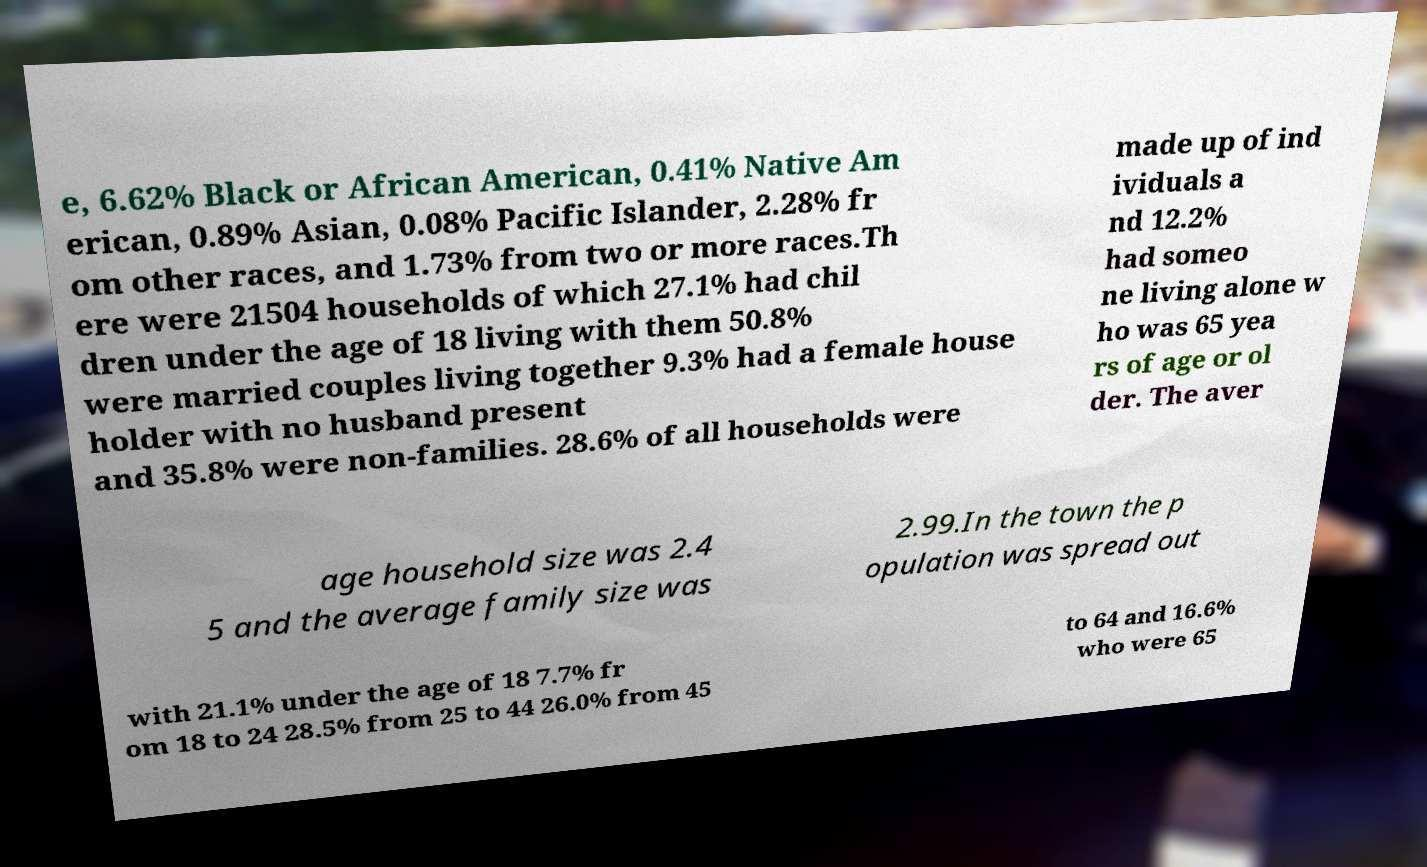Please read and relay the text visible in this image. What does it say? e, 6.62% Black or African American, 0.41% Native Am erican, 0.89% Asian, 0.08% Pacific Islander, 2.28% fr om other races, and 1.73% from two or more races.Th ere were 21504 households of which 27.1% had chil dren under the age of 18 living with them 50.8% were married couples living together 9.3% had a female house holder with no husband present and 35.8% were non-families. 28.6% of all households were made up of ind ividuals a nd 12.2% had someo ne living alone w ho was 65 yea rs of age or ol der. The aver age household size was 2.4 5 and the average family size was 2.99.In the town the p opulation was spread out with 21.1% under the age of 18 7.7% fr om 18 to 24 28.5% from 25 to 44 26.0% from 45 to 64 and 16.6% who were 65 